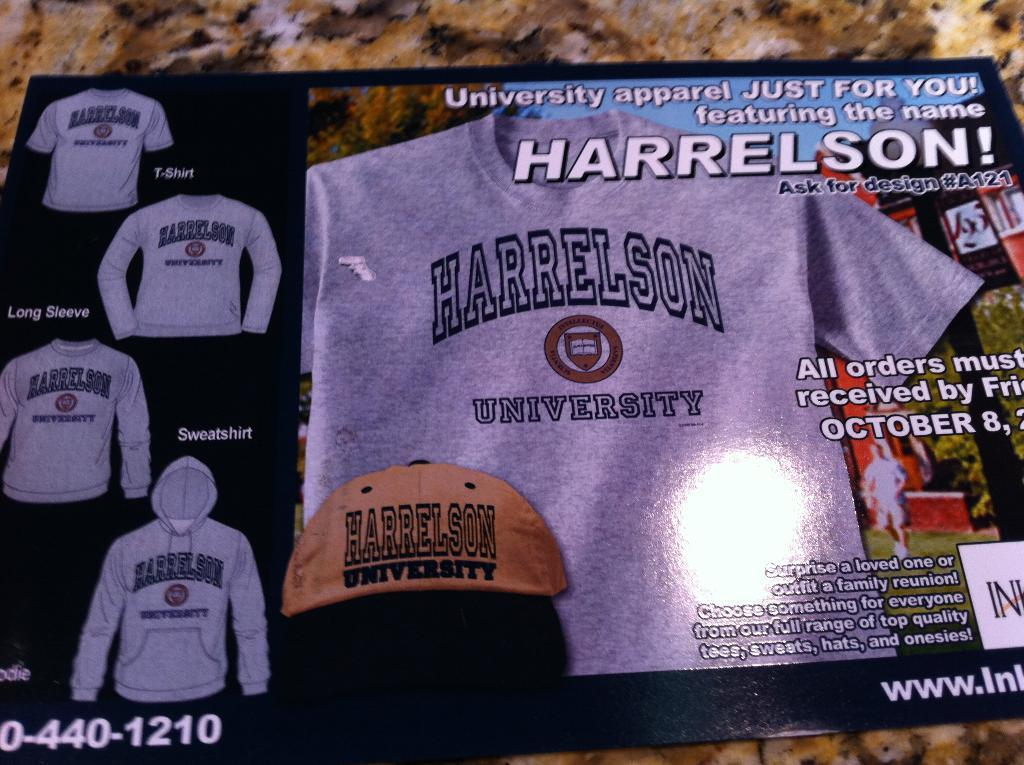<image>
Relay a brief, clear account of the picture shown. A picture of a tee shirt with the words Harrelson University on it. 